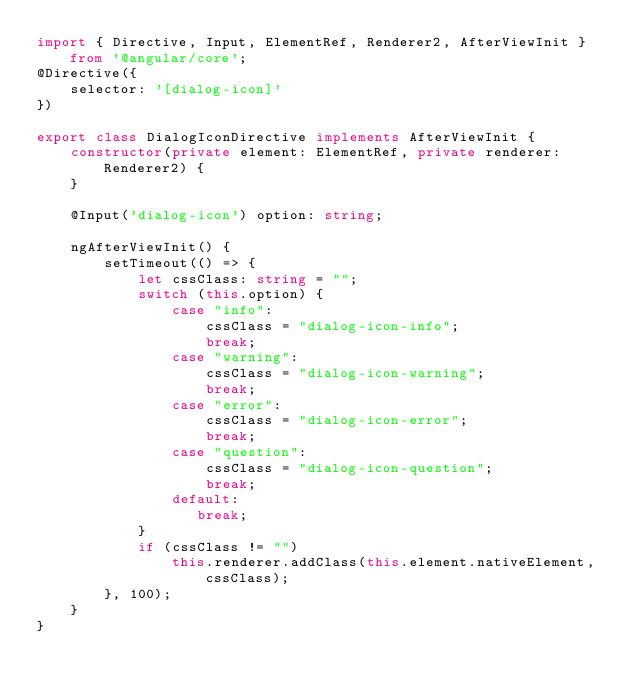<code> <loc_0><loc_0><loc_500><loc_500><_TypeScript_>import { Directive, Input, ElementRef, Renderer2, AfterViewInit } from '@angular/core';
@Directive({
    selector: '[dialog-icon]'
})

export class DialogIconDirective implements AfterViewInit {
    constructor(private element: ElementRef, private renderer: Renderer2) {
    }
    
    @Input('dialog-icon') option: string;
    
    ngAfterViewInit() {        
        setTimeout(() => {
            let cssClass: string = "";
            switch (this.option) {
                case "info":
                    cssClass = "dialog-icon-info";
                    break;
                case "warning":
                    cssClass = "dialog-icon-warning";
                    break;
                case "error":
                    cssClass = "dialog-icon-error";
                    break;
                case "question":
                    cssClass = "dialog-icon-question";
                    break;                
                default:
                   break;
            }
            if (cssClass != "")
                this.renderer.addClass(this.element.nativeElement, cssClass);
        }, 100);        
    }
}
</code> 